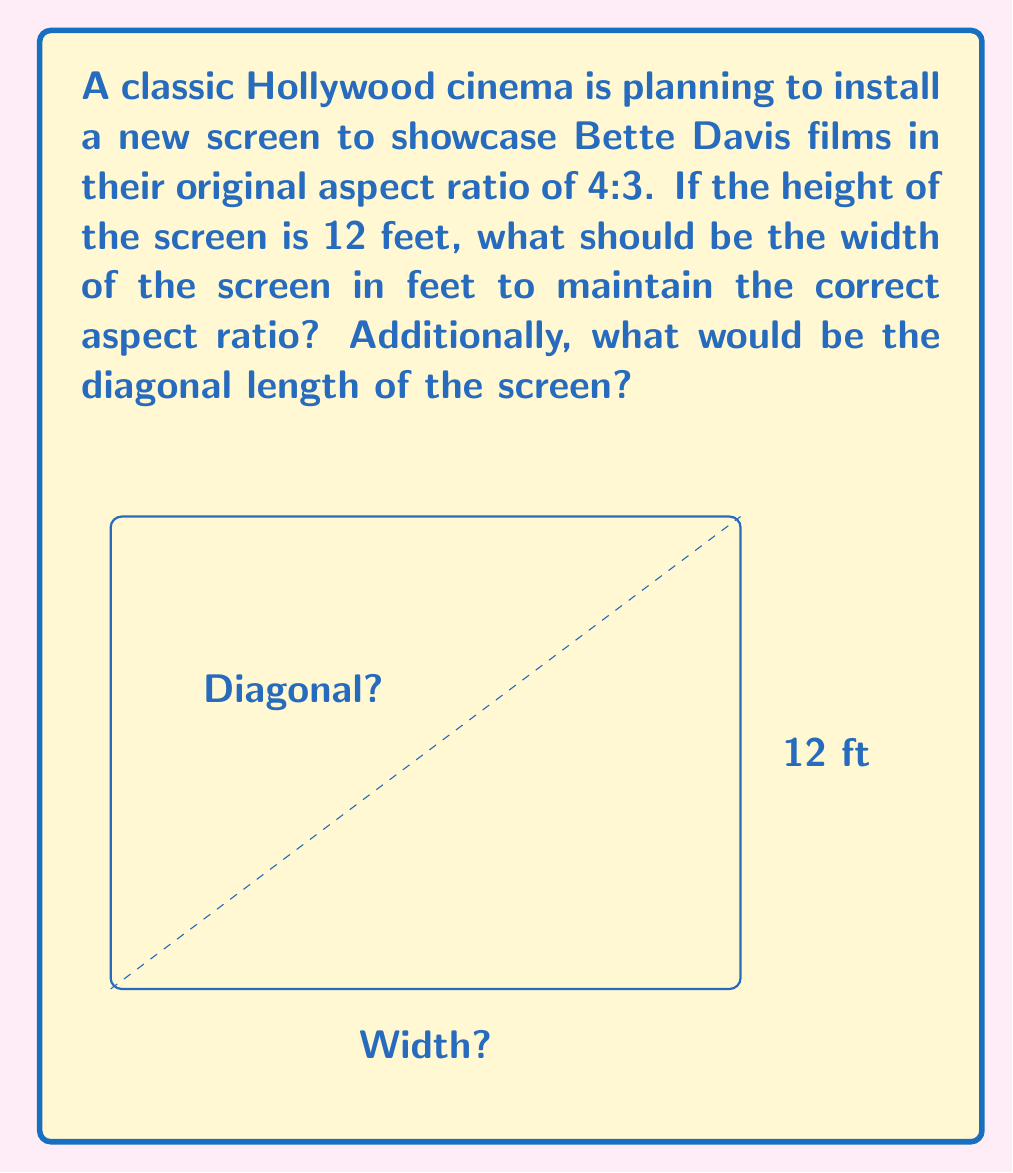Can you solve this math problem? Let's approach this step-by-step:

1) The aspect ratio of 4:3 means that for every 3 units of height, there are 4 units of width.

2) We're given that the height is 12 feet. Let's call the width $w$.

3) To maintain the aspect ratio, we can set up the following proportion:
   $$ \frac{w}{12} = \frac{4}{3} $$

4) Cross-multiplying, we get:
   $$ 3w = 48 $$

5) Solving for $w$:
   $$ w = \frac{48}{3} = 16 $$

6) So the width should be 16 feet.

7) For the diagonal length, we can use the Pythagorean theorem. If we call the diagonal $d$:
   $$ d^2 = 12^2 + 16^2 $$

8) Simplifying:
   $$ d^2 = 144 + 256 = 400 $$

9) Taking the square root of both sides:
   $$ d = \sqrt{400} = 20 $$

Therefore, the width should be 16 feet, and the diagonal length would be 20 feet.
Answer: Width: 16 ft, Diagonal: 20 ft 